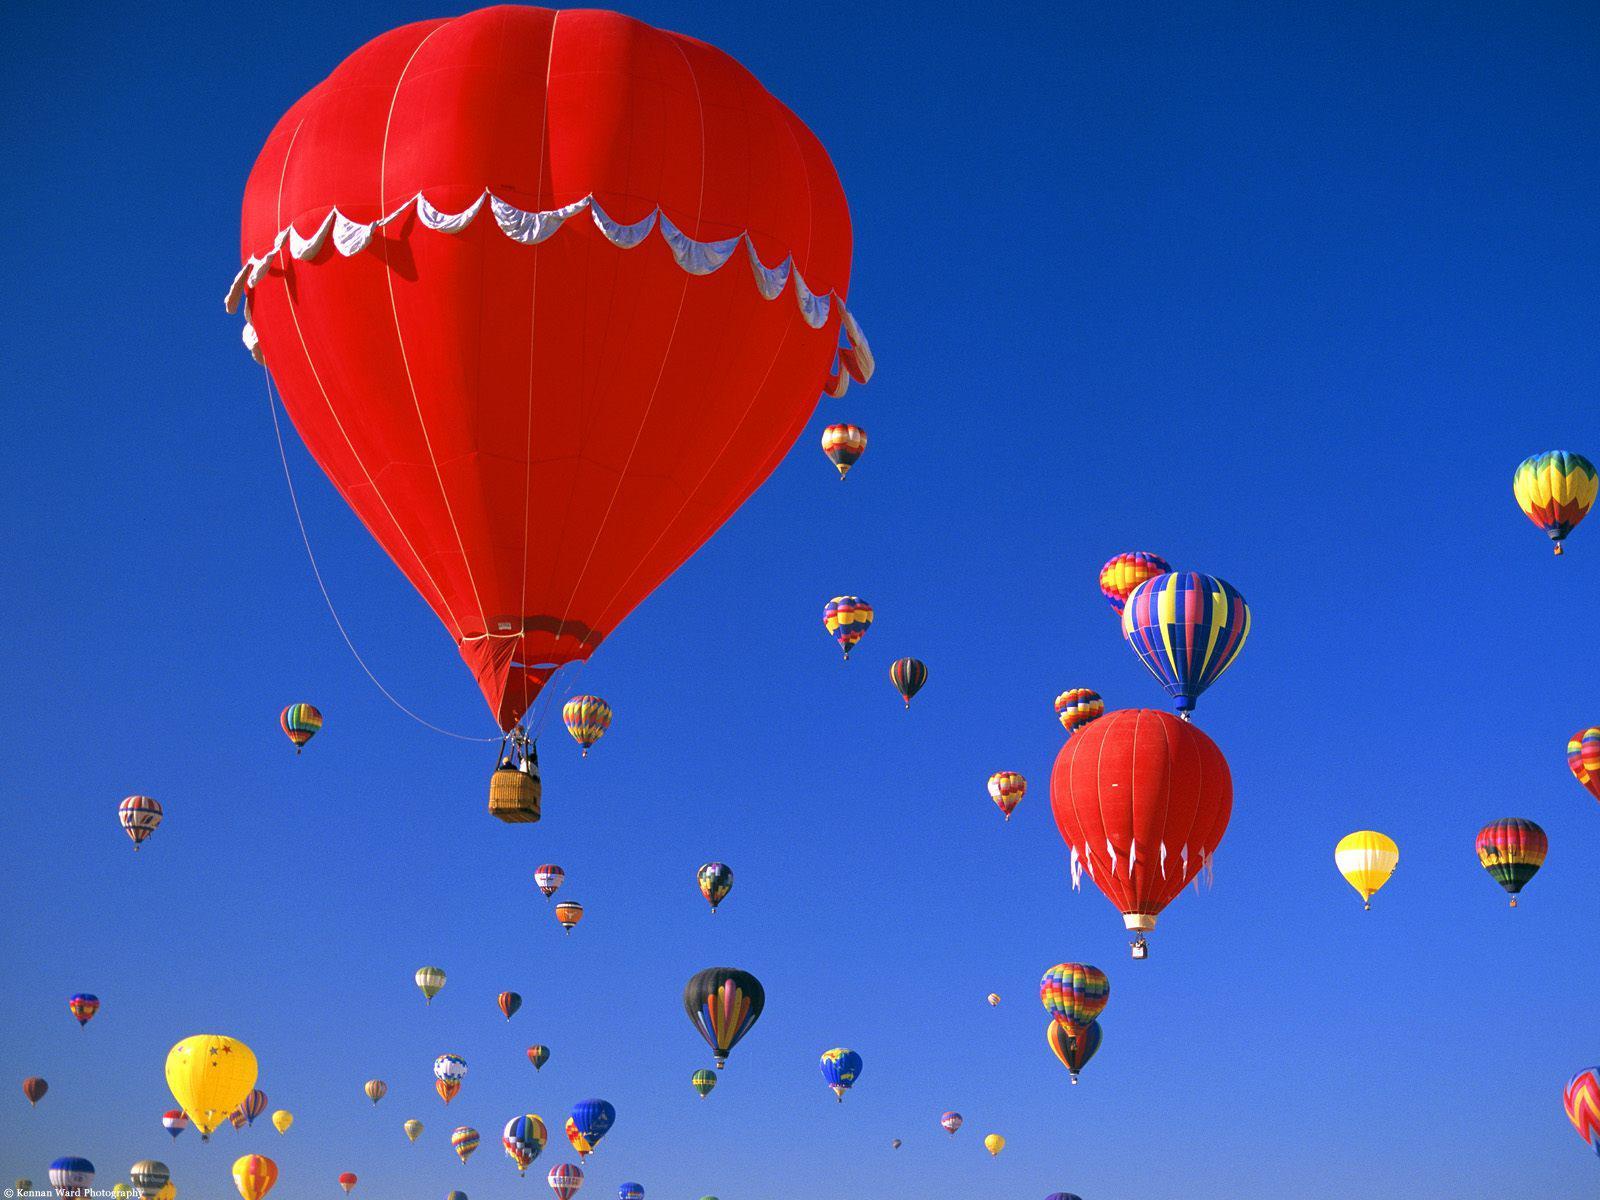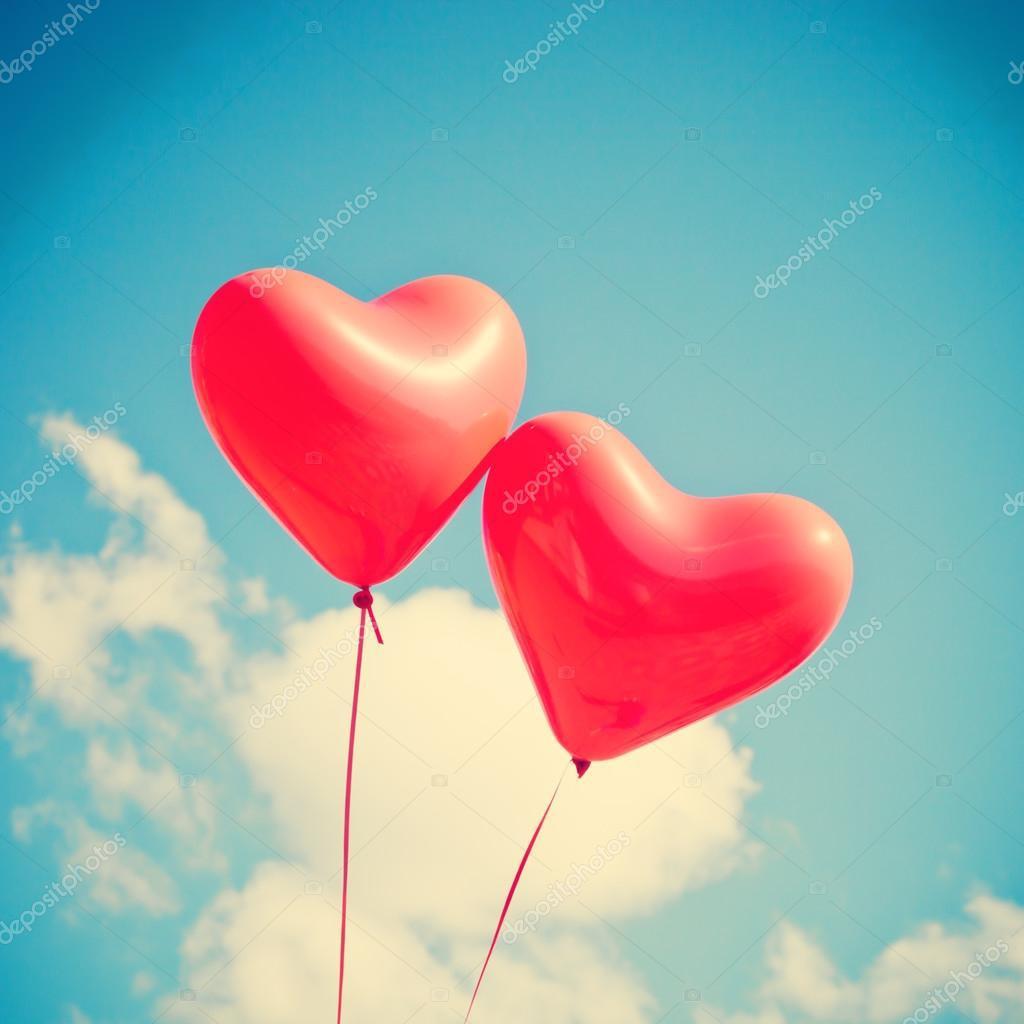The first image is the image on the left, the second image is the image on the right. Evaluate the accuracy of this statement regarding the images: "The right image has no more than 2 balloons.". Is it true? Answer yes or no. Yes. The first image is the image on the left, the second image is the image on the right. Analyze the images presented: Is the assertion "There are no more than two balloons in the sky in the image on the right." valid? Answer yes or no. Yes. 